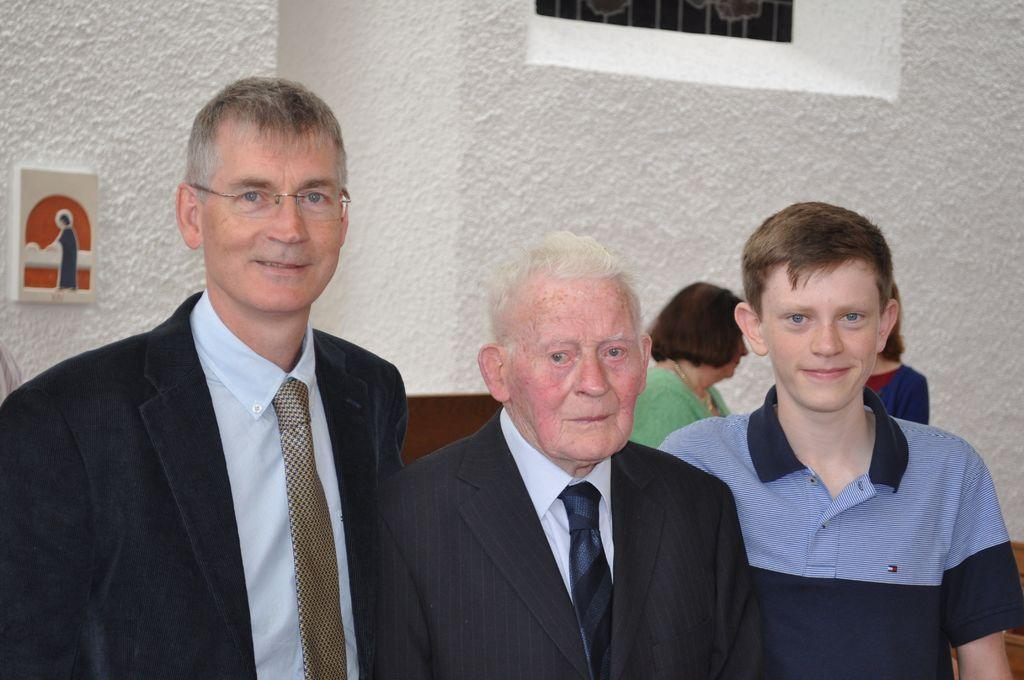How many people are in the image? There are three members in the image. What type of clothing are two of them wearing? Two of them are wearing coats. What type of clothing is the third person wearing? One of them is wearing a T-shirt. What can be seen in the background of the image? There is a wall in the background of the image. What type of writer can be seen in the image? There is no writer present in the image. What view can be seen from the location of the image? The image does not provide information about the view from the location. 